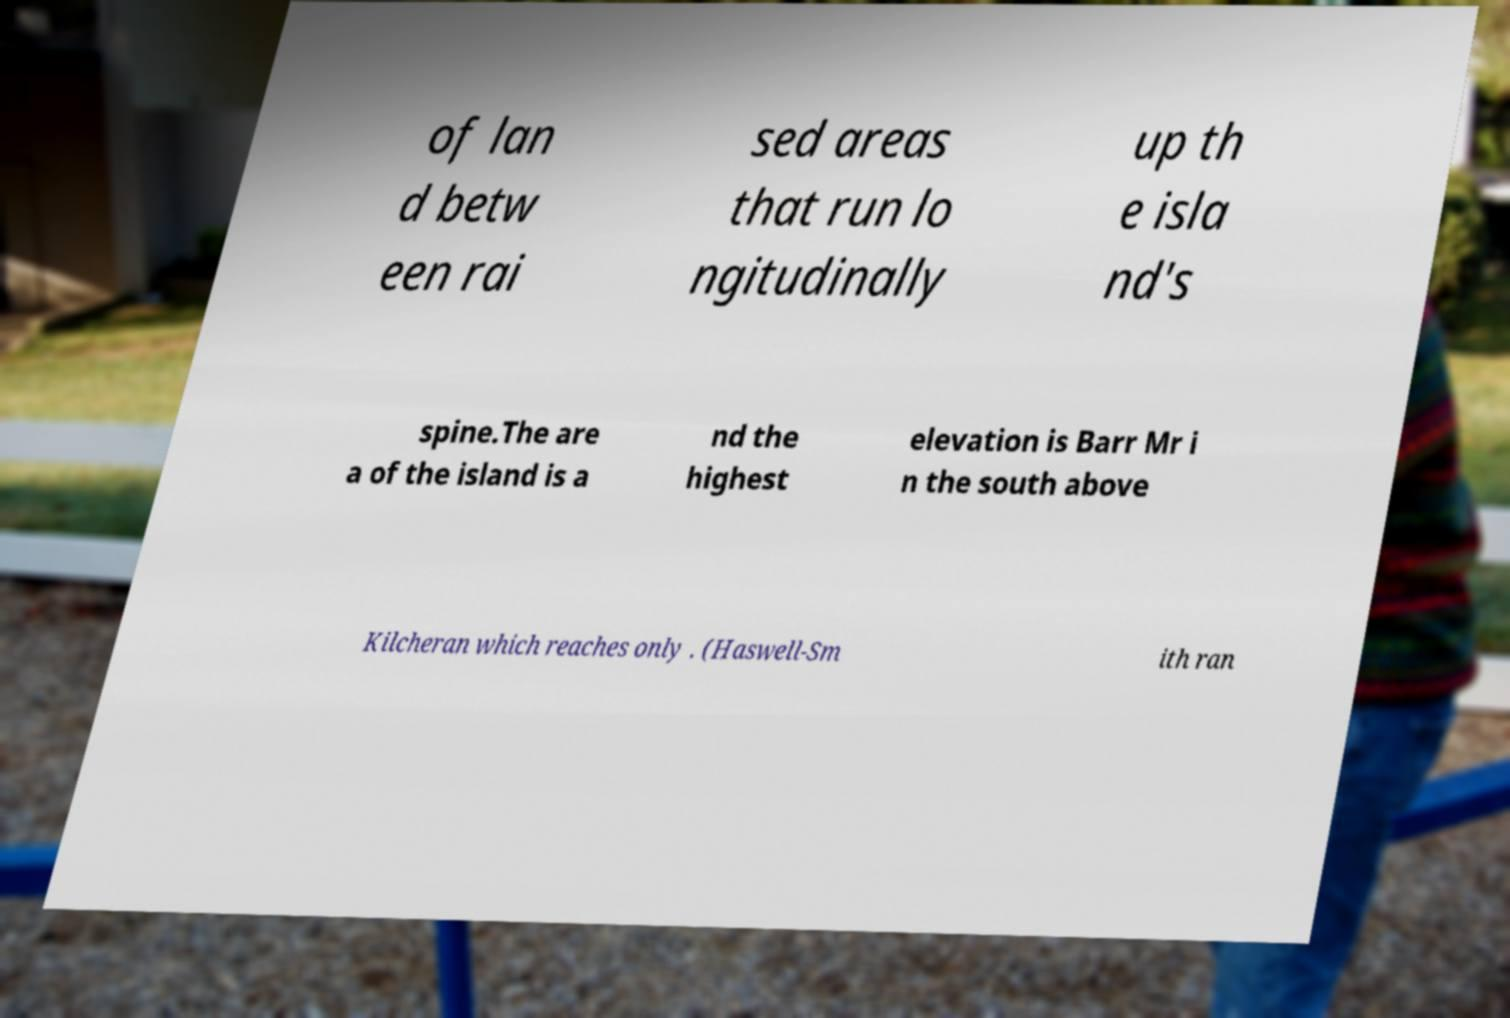Could you assist in decoding the text presented in this image and type it out clearly? of lan d betw een rai sed areas that run lo ngitudinally up th e isla nd's spine.The are a of the island is a nd the highest elevation is Barr Mr i n the south above Kilcheran which reaches only . (Haswell-Sm ith ran 